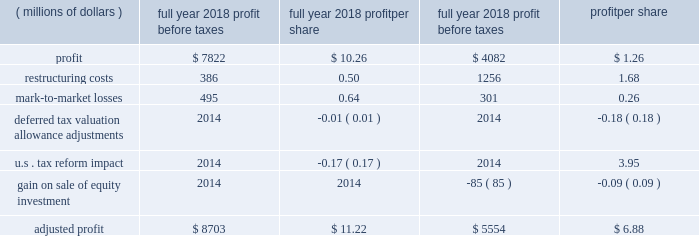2018 a0form 10-k18 item 7 .
Management 2019s discussion and analysis of financial condition and results of operations .
This management 2019s discussion and analysis of financial condition and results of operations should be read in conjunction with our discussion of cautionary statements and significant risks to the company 2019s business under item 1a .
Risk factors of the 2018 form a010-k .
Overview our sales and revenues for 2018 were $ 54.722 billion , a 20 a0percent increase from 2017 sales and revenues of $ 45.462 a0billion .
The increase was primarily due to higher sales volume , mostly due to improved demand across all regions and across the three primary segments .
Profit per share for 2018 was $ 10.26 , compared to profit per share of $ 1.26 in 2017 .
Profit was $ 6.147 billion in 2018 , compared with $ 754 million in 2017 .
The increase was primarily due to lower tax expense , higher sales volume , decreased restructuring costs and improved price realization .
The increase was partially offset by higher manufacturing costs and selling , general and administrative ( sg&a ) and research and development ( r&d ) expenses and lower profit from the financial products segment .
Fourth-quarter 2018 sales and revenues were $ 14.342 billion , up $ 1.446 billion , or 11 percent , from $ 12.896 billion in the fourth quarter of 2017 .
Fourth-quarter 2018 profit was $ 1.78 per share , compared with a loss of $ 2.18 per share in the fourth quarter of 2017 .
Fourth-quarter 2018 profit was $ 1.048 billion , compared with a loss of $ 1.299 billion in 2017 .
Highlights for 2018 include : zz sales and revenues in 2018 were $ 54.722 billion , up 20 a0percent from 2017 .
Sales improved in all regions and across the three primary segments .
Zz operating profit as a percent of sales and revenues was 15.2 a0percent in 2018 , compared with 9.8 percent in 2017 .
Adjusted operating profit margin was 15.9 percent in 2018 , compared with 12.5 percent in 2017 .
Zz profit was $ 10.26 per share for 2018 , and excluding the items in the table below , adjusted profit per share was $ 11.22 .
For 2017 profit was $ 1.26 per share , and excluding the items in the table below , adjusted profit per share was $ 6.88 .
Zz in order for our results to be more meaningful to our readers , we have separately quantified the impact of several significant items: .
Zz machinery , energy & transportation ( me&t ) operating cash flow for 2018 was about $ 6.3 billion , more than sufficient to cover capital expenditures and dividends .
Me&t operating cash flow for 2017 was about $ 5.5 billion .
Restructuring costs in recent years , we have incurred substantial restructuring costs to achieve a flexible and competitive cost structure .
During 2018 , we incurred $ 386 million of restructuring costs related to restructuring actions across the company .
During 2017 , we incurred $ 1.256 billion of restructuring costs with about half related to the closure of the facility in gosselies , belgium , and the remainder related to other restructuring actions across the company .
Although we expect restructuring to continue as part of ongoing business activities , restructuring costs should be lower in 2019 than 2018 .
Notes : zz glossary of terms included on pages 33-34 ; first occurrence of terms shown in bold italics .
Zz information on non-gaap financial measures is included on pages 42-43. .
What is the net change in sales and revenues from 2017 to 2018 , in billions? 
Computations: (54.722 - 45.462)
Answer: 9.26. 